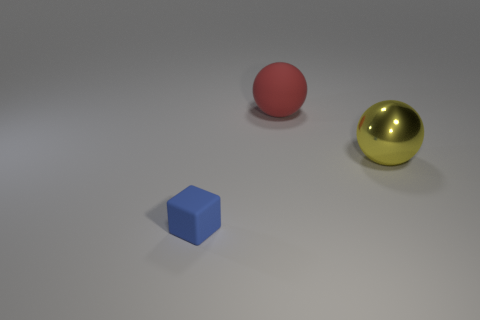What number of other things are there of the same color as the tiny thing?
Your response must be concise. 0. Are there any large red matte spheres behind the large red thing?
Provide a succinct answer. No. The thing behind the sphere to the right of the large ball that is behind the large shiny ball is what color?
Offer a terse response. Red. How many things are both to the right of the tiny blue thing and in front of the red sphere?
Your answer should be very brief. 1. How many blocks are big cyan rubber objects or small blue rubber objects?
Provide a short and direct response. 1. Are there any tiny green balls?
Your response must be concise. No. What number of other things are the same material as the small blue block?
Ensure brevity in your answer.  1. What is the material of the other object that is the same size as the yellow shiny object?
Your response must be concise. Rubber. Is the shape of the small blue object that is on the left side of the big red rubber object the same as  the big red object?
Keep it short and to the point. No. Does the metallic ball have the same color as the rubber sphere?
Give a very brief answer. No. 